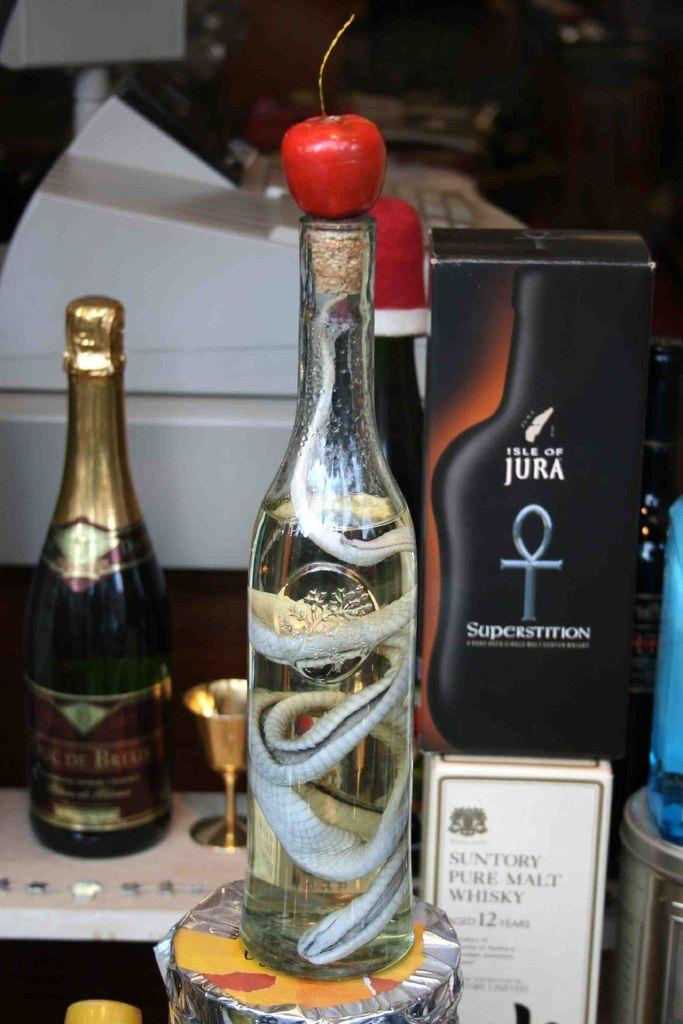<image>
Describe the image concisely. A box with a picture of a black bottle that says, "Isle of Jura." 